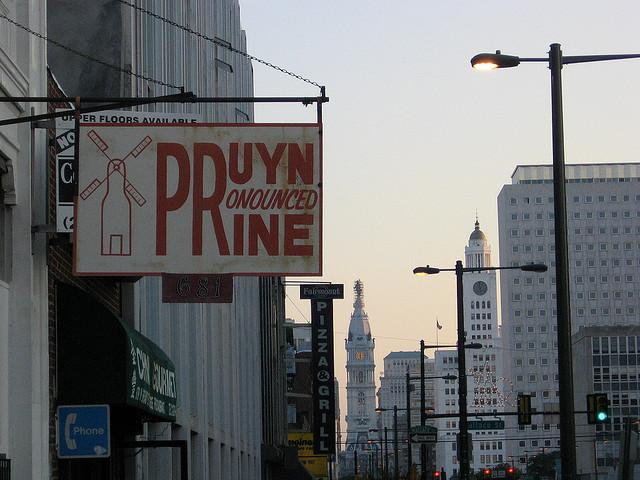Which way is illegal to turn on the upcoming cross street?

Choices:
A) right
B) straight
C) none
D) left right 